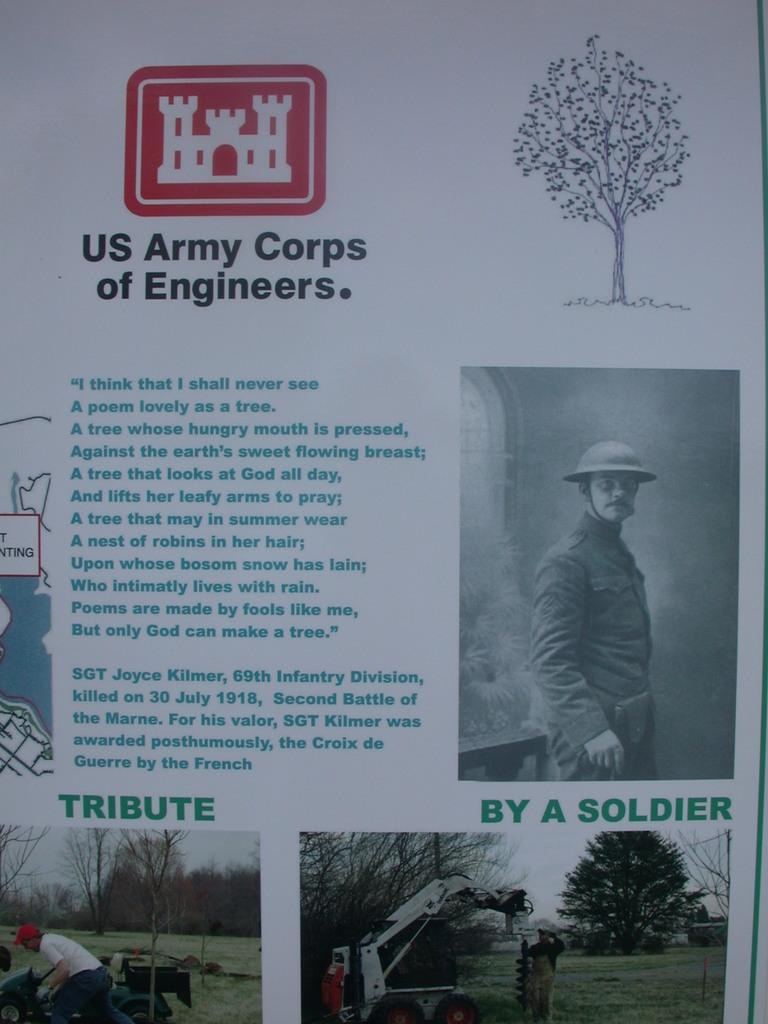What type of visual is the image? The image is a poster. What can be found on the poster? There is text on the poster. Who or what can be seen in the image? There are people depicted in the image. What type of natural environment is shown in the image? Trees and grass are present in the image. What else is visible in the image? A vehicle and some objects are visible in the image. Where is the nest located in the image? There is no nest present in the image. What type of industry is depicted in the image? The image does not depict any industry; it is a poster with people, text, and a natural environment. 